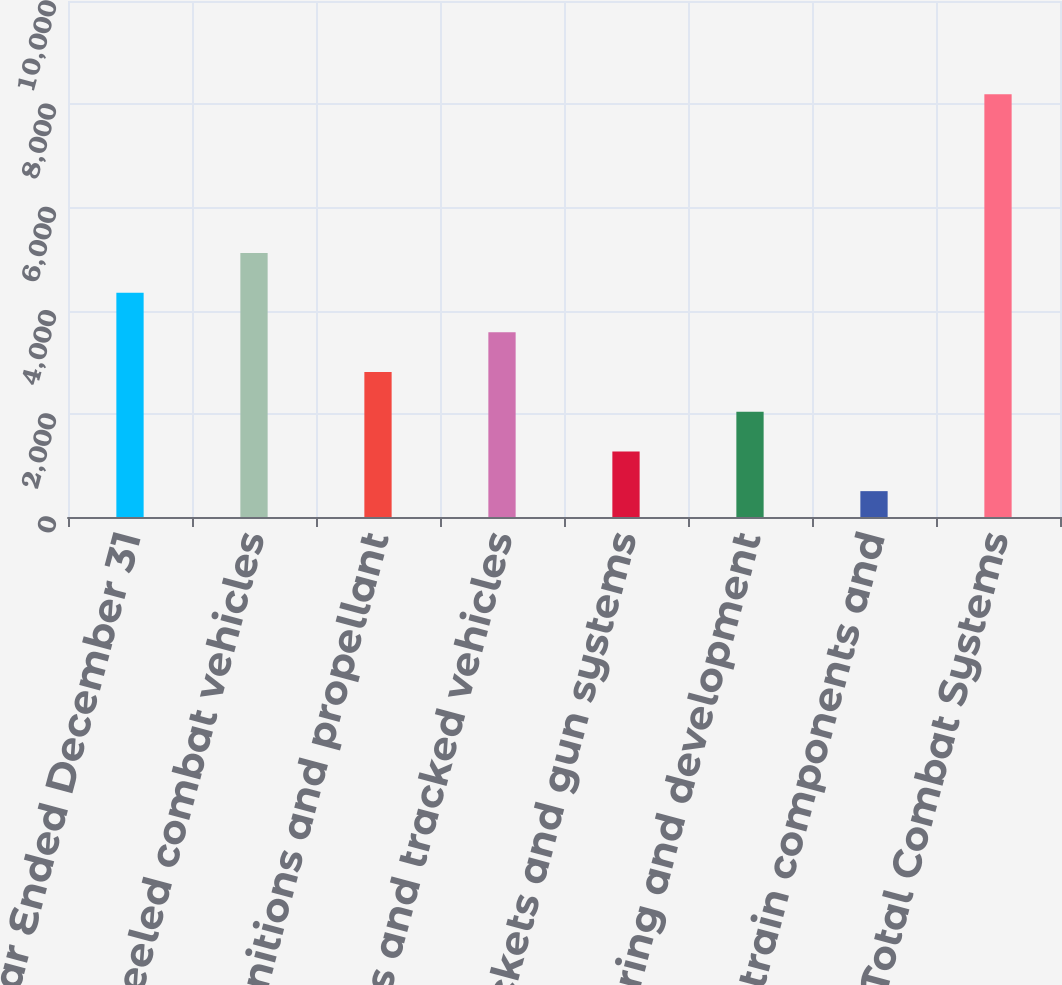Convert chart. <chart><loc_0><loc_0><loc_500><loc_500><bar_chart><fcel>Year Ended December 31<fcel>Wheeled combat vehicles<fcel>Munitions and propellant<fcel>Tanks and tracked vehicles<fcel>Rockets and gun systems<fcel>Engineering and development<fcel>Drivetrain components and<fcel>Total Combat Systems<nl><fcel>4347.5<fcel>5116.8<fcel>2808.9<fcel>3578.2<fcel>1270.3<fcel>2039.6<fcel>501<fcel>8194<nl></chart> 